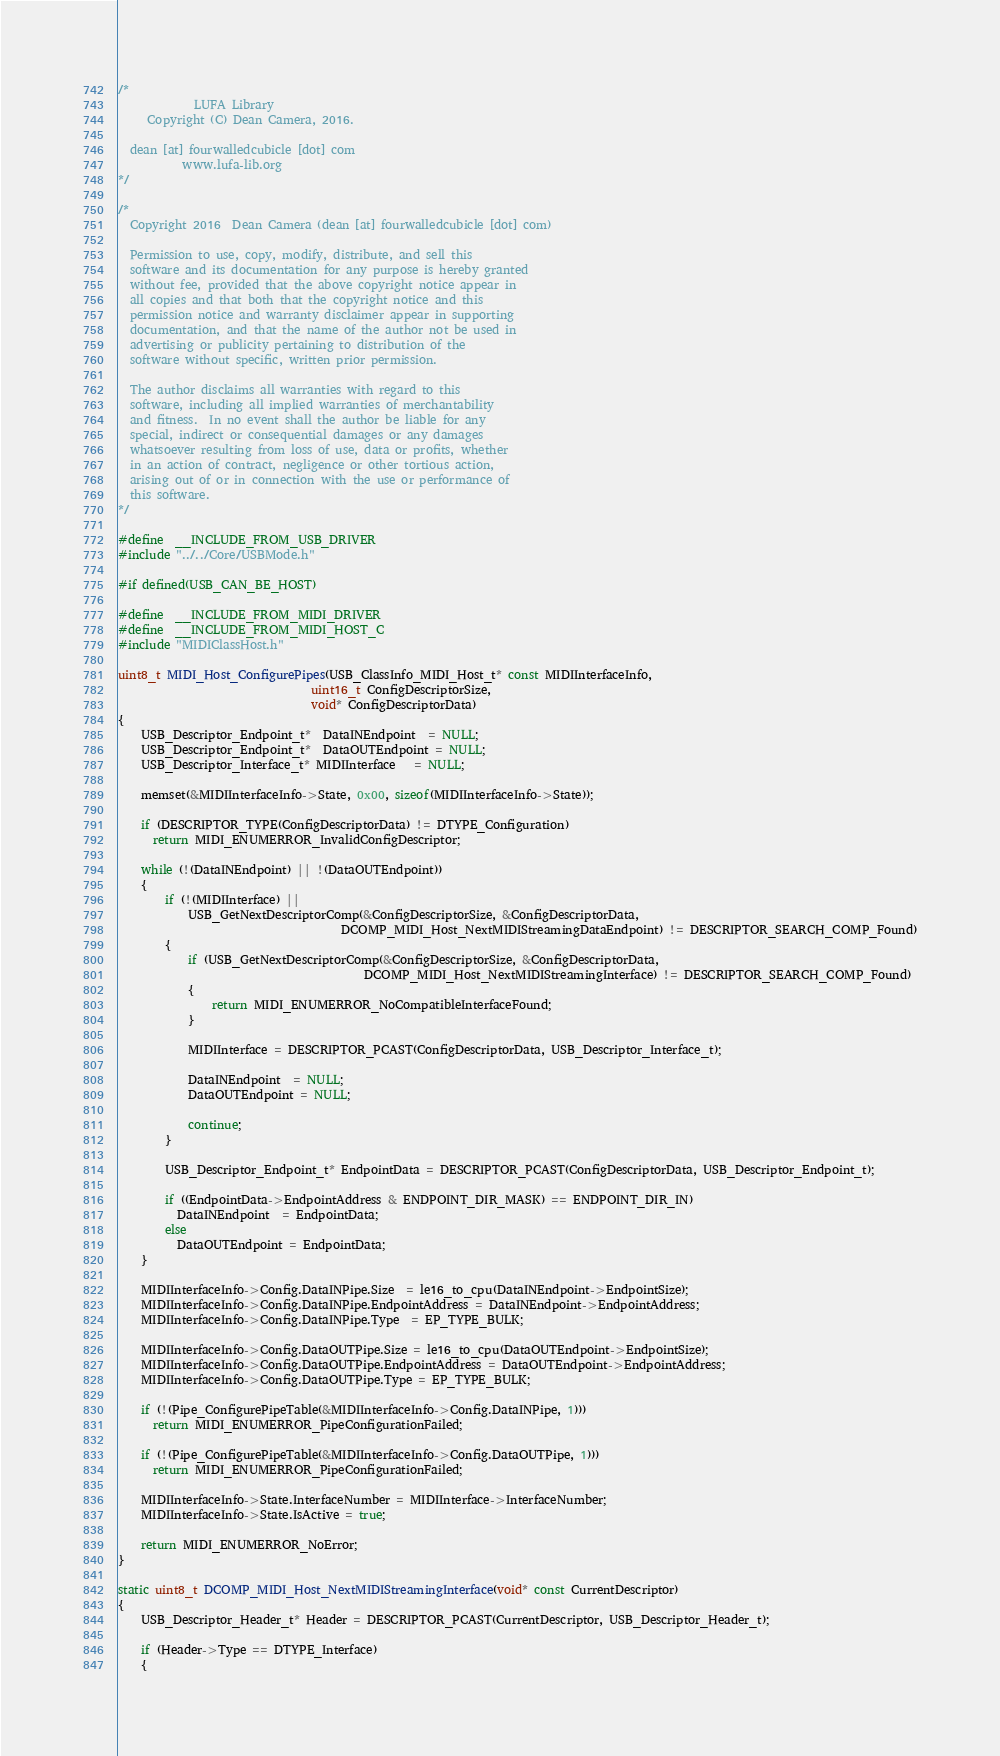Convert code to text. <code><loc_0><loc_0><loc_500><loc_500><_C_>/*
             LUFA Library
     Copyright (C) Dean Camera, 2016.

  dean [at] fourwalledcubicle [dot] com
           www.lufa-lib.org
*/

/*
  Copyright 2016  Dean Camera (dean [at] fourwalledcubicle [dot] com)

  Permission to use, copy, modify, distribute, and sell this
  software and its documentation for any purpose is hereby granted
  without fee, provided that the above copyright notice appear in
  all copies and that both that the copyright notice and this
  permission notice and warranty disclaimer appear in supporting
  documentation, and that the name of the author not be used in
  advertising or publicity pertaining to distribution of the
  software without specific, written prior permission.

  The author disclaims all warranties with regard to this
  software, including all implied warranties of merchantability
  and fitness.  In no event shall the author be liable for any
  special, indirect or consequential damages or any damages
  whatsoever resulting from loss of use, data or profits, whether
  in an action of contract, negligence or other tortious action,
  arising out of or in connection with the use or performance of
  this software.
*/

#define  __INCLUDE_FROM_USB_DRIVER
#include "../../Core/USBMode.h"

#if defined(USB_CAN_BE_HOST)

#define  __INCLUDE_FROM_MIDI_DRIVER
#define  __INCLUDE_FROM_MIDI_HOST_C
#include "MIDIClassHost.h"

uint8_t MIDI_Host_ConfigurePipes(USB_ClassInfo_MIDI_Host_t* const MIDIInterfaceInfo,
                                 uint16_t ConfigDescriptorSize,
                                 void* ConfigDescriptorData)
{
	USB_Descriptor_Endpoint_t*  DataINEndpoint  = NULL;
	USB_Descriptor_Endpoint_t*  DataOUTEndpoint = NULL;
	USB_Descriptor_Interface_t* MIDIInterface   = NULL;

	memset(&MIDIInterfaceInfo->State, 0x00, sizeof(MIDIInterfaceInfo->State));

	if (DESCRIPTOR_TYPE(ConfigDescriptorData) != DTYPE_Configuration)
	  return MIDI_ENUMERROR_InvalidConfigDescriptor;

	while (!(DataINEndpoint) || !(DataOUTEndpoint))
	{
		if (!(MIDIInterface) ||
		    USB_GetNextDescriptorComp(&ConfigDescriptorSize, &ConfigDescriptorData,
		                              DCOMP_MIDI_Host_NextMIDIStreamingDataEndpoint) != DESCRIPTOR_SEARCH_COMP_Found)
		{
			if (USB_GetNextDescriptorComp(&ConfigDescriptorSize, &ConfigDescriptorData,
			                              DCOMP_MIDI_Host_NextMIDIStreamingInterface) != DESCRIPTOR_SEARCH_COMP_Found)
			{
				return MIDI_ENUMERROR_NoCompatibleInterfaceFound;
			}

			MIDIInterface = DESCRIPTOR_PCAST(ConfigDescriptorData, USB_Descriptor_Interface_t);

			DataINEndpoint  = NULL;
			DataOUTEndpoint = NULL;

			continue;
		}

		USB_Descriptor_Endpoint_t* EndpointData = DESCRIPTOR_PCAST(ConfigDescriptorData, USB_Descriptor_Endpoint_t);

		if ((EndpointData->EndpointAddress & ENDPOINT_DIR_MASK) == ENDPOINT_DIR_IN)
		  DataINEndpoint  = EndpointData;
		else
		  DataOUTEndpoint = EndpointData;
	}

	MIDIInterfaceInfo->Config.DataINPipe.Size  = le16_to_cpu(DataINEndpoint->EndpointSize);
	MIDIInterfaceInfo->Config.DataINPipe.EndpointAddress = DataINEndpoint->EndpointAddress;
	MIDIInterfaceInfo->Config.DataINPipe.Type  = EP_TYPE_BULK;

	MIDIInterfaceInfo->Config.DataOUTPipe.Size = le16_to_cpu(DataOUTEndpoint->EndpointSize);
	MIDIInterfaceInfo->Config.DataOUTPipe.EndpointAddress = DataOUTEndpoint->EndpointAddress;
	MIDIInterfaceInfo->Config.DataOUTPipe.Type = EP_TYPE_BULK;

	if (!(Pipe_ConfigurePipeTable(&MIDIInterfaceInfo->Config.DataINPipe, 1)))
	  return MIDI_ENUMERROR_PipeConfigurationFailed;

	if (!(Pipe_ConfigurePipeTable(&MIDIInterfaceInfo->Config.DataOUTPipe, 1)))
	  return MIDI_ENUMERROR_PipeConfigurationFailed;

	MIDIInterfaceInfo->State.InterfaceNumber = MIDIInterface->InterfaceNumber;
	MIDIInterfaceInfo->State.IsActive = true;

	return MIDI_ENUMERROR_NoError;
}

static uint8_t DCOMP_MIDI_Host_NextMIDIStreamingInterface(void* const CurrentDescriptor)
{
	USB_Descriptor_Header_t* Header = DESCRIPTOR_PCAST(CurrentDescriptor, USB_Descriptor_Header_t);

	if (Header->Type == DTYPE_Interface)
	{</code> 